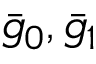<formula> <loc_0><loc_0><loc_500><loc_500>\bar { g } _ { 0 } , \bar { g } _ { 1 }</formula> 